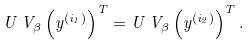<formula> <loc_0><loc_0><loc_500><loc_500>U \, V _ { \beta } \left ( y ^ { \left ( i _ { 1 } \right ) } \right ) ^ { T } = U \, V _ { \beta } \left ( y ^ { \left ( i _ { 2 } \right ) } \right ) ^ { T } .</formula> 